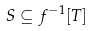Convert formula to latex. <formula><loc_0><loc_0><loc_500><loc_500>S \subseteq f ^ { - 1 } [ T ]</formula> 